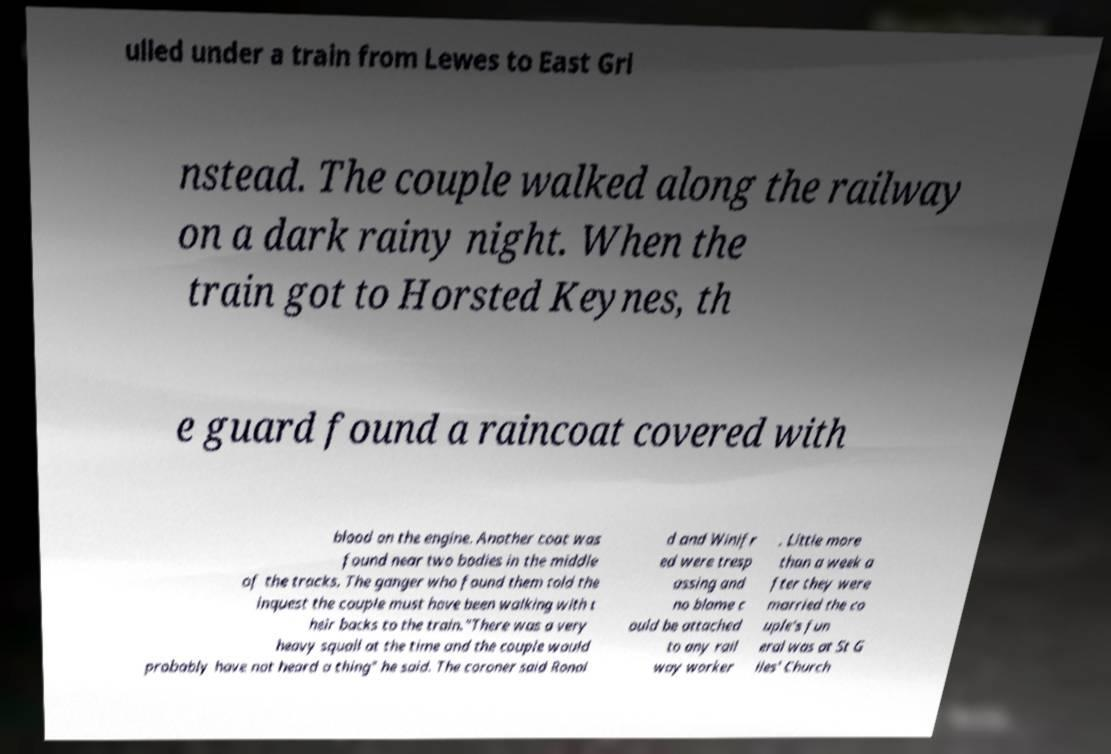Could you extract and type out the text from this image? ulled under a train from Lewes to East Gri nstead. The couple walked along the railway on a dark rainy night. When the train got to Horsted Keynes, th e guard found a raincoat covered with blood on the engine. Another coat was found near two bodies in the middle of the tracks. The ganger who found them told the inquest the couple must have been walking with t heir backs to the train."There was a very heavy squall at the time and the couple would probably have not heard a thing" he said. The coroner said Ronal d and Winifr ed were tresp assing and no blame c ould be attached to any rail way worker . Little more than a week a fter they were married the co uple's fun eral was at St G iles' Church 